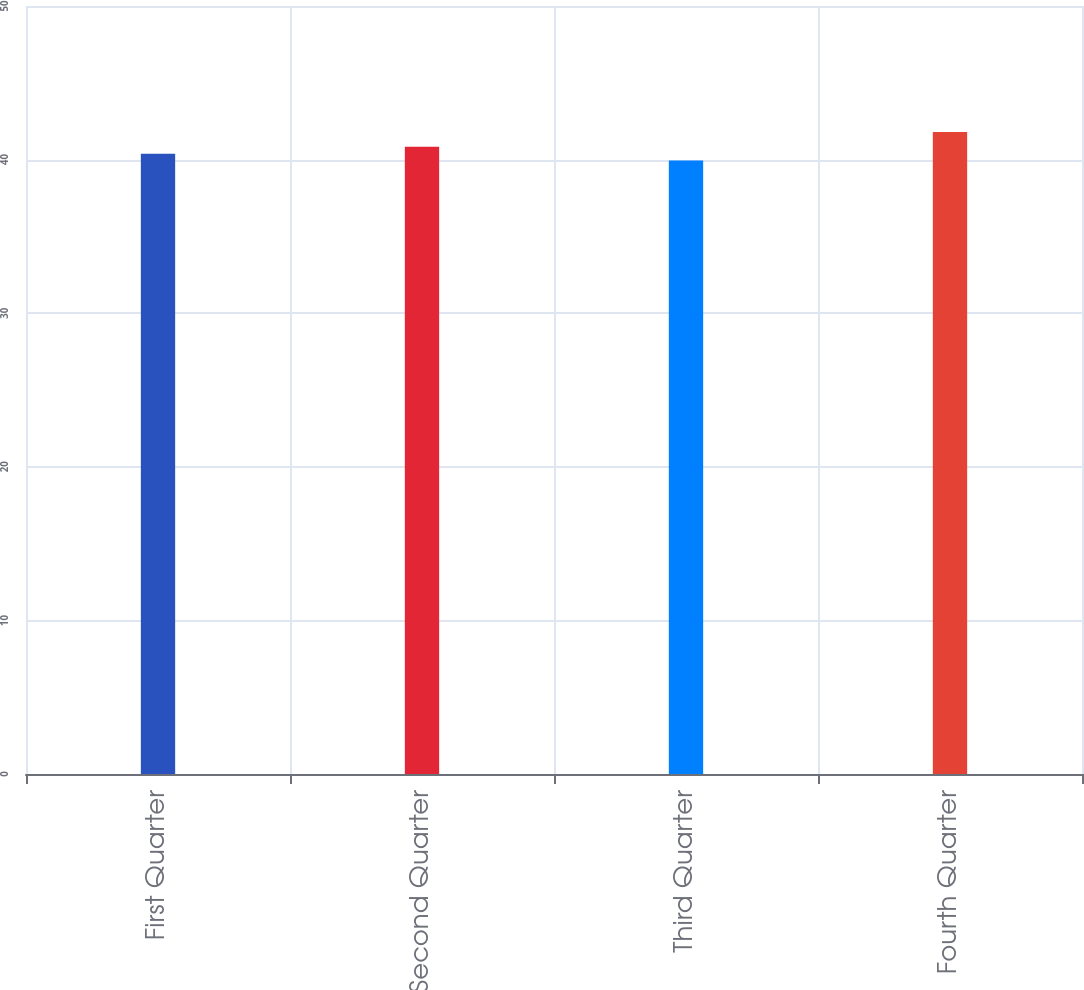Convert chart to OTSL. <chart><loc_0><loc_0><loc_500><loc_500><bar_chart><fcel>First Quarter<fcel>Second Quarter<fcel>Third Quarter<fcel>Fourth Quarter<nl><fcel>40.38<fcel>40.83<fcel>39.94<fcel>41.79<nl></chart> 